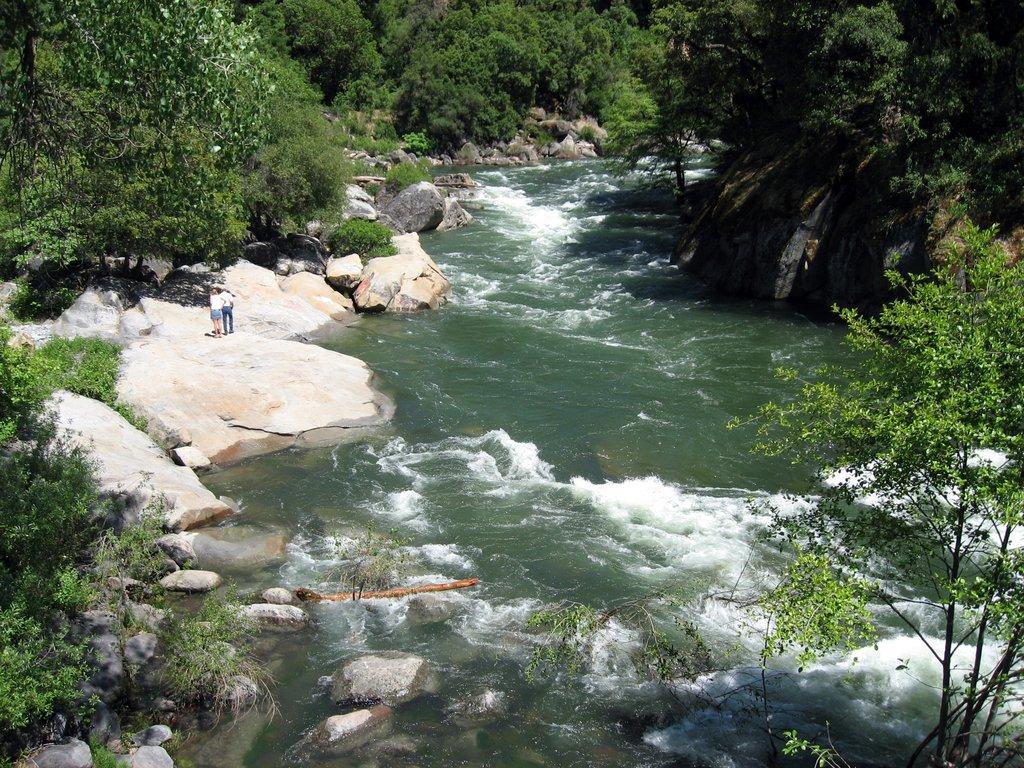How would you summarize this image in a sentence or two? In the center of the image there is a canal. On the left there are two people standing. On the right there is a rock. In the background we can see trees. 